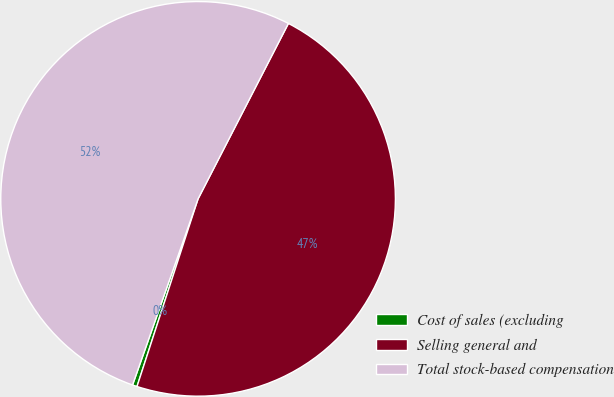<chart> <loc_0><loc_0><loc_500><loc_500><pie_chart><fcel>Cost of sales (excluding<fcel>Selling general and<fcel>Total stock-based compensation<nl><fcel>0.38%<fcel>47.44%<fcel>52.18%<nl></chart> 